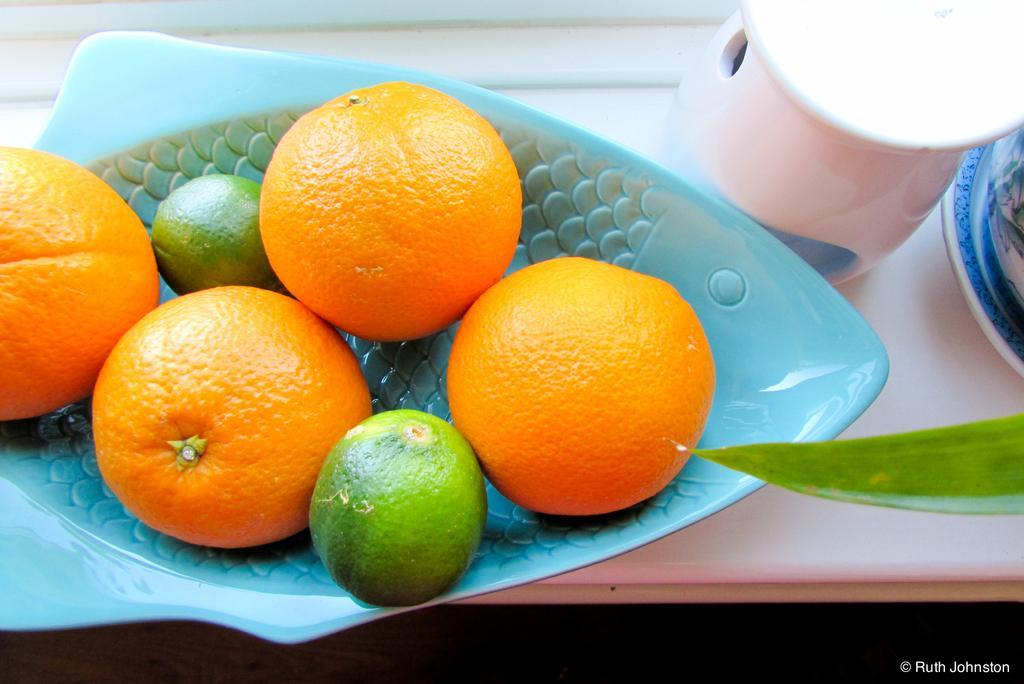Could you give a brief overview of what you see in this image? In front of the image there is a leaf. There is a table. On top of it there are oranges and lemons in the tray. Beside the tree there are some other objects. There is some text at the bottom of the image. 